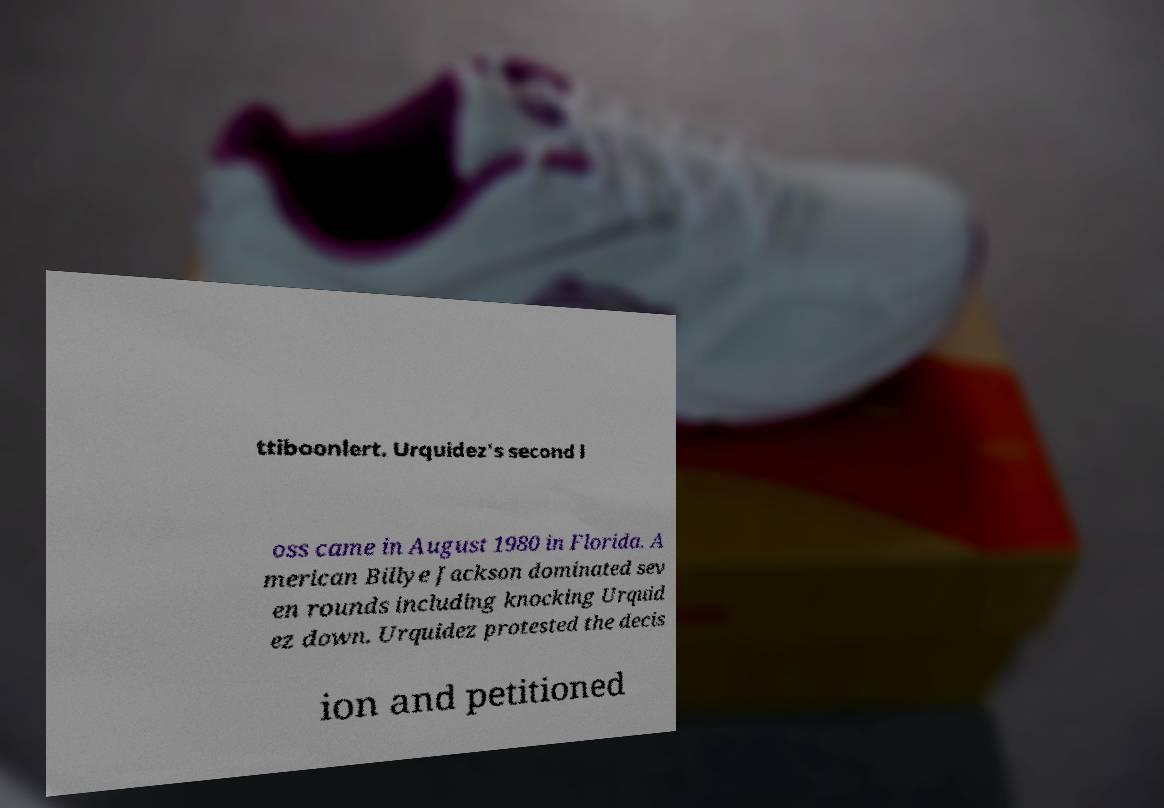For documentation purposes, I need the text within this image transcribed. Could you provide that? ttiboonlert. Urquidez's second l oss came in August 1980 in Florida. A merican Billye Jackson dominated sev en rounds including knocking Urquid ez down. Urquidez protested the decis ion and petitioned 